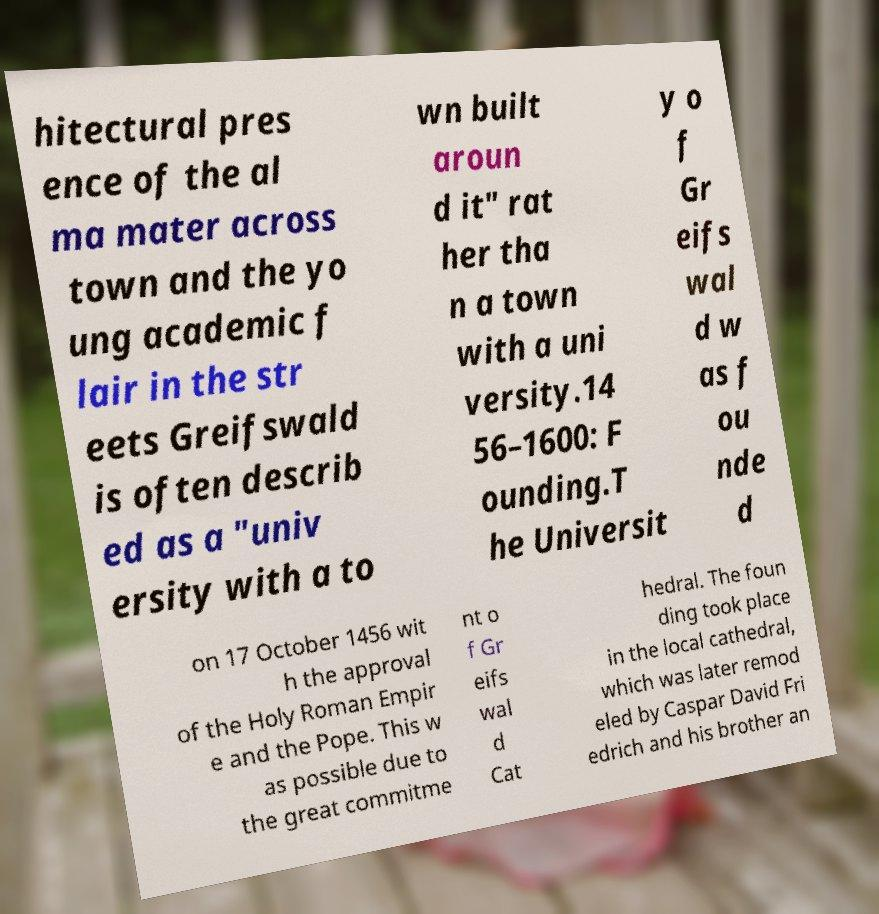For documentation purposes, I need the text within this image transcribed. Could you provide that? hitectural pres ence of the al ma mater across town and the yo ung academic f lair in the str eets Greifswald is often describ ed as a "univ ersity with a to wn built aroun d it" rat her tha n a town with a uni versity.14 56–1600: F ounding.T he Universit y o f Gr eifs wal d w as f ou nde d on 17 October 1456 wit h the approval of the Holy Roman Empir e and the Pope. This w as possible due to the great commitme nt o f Gr eifs wal d Cat hedral. The foun ding took place in the local cathedral, which was later remod eled by Caspar David Fri edrich and his brother an 